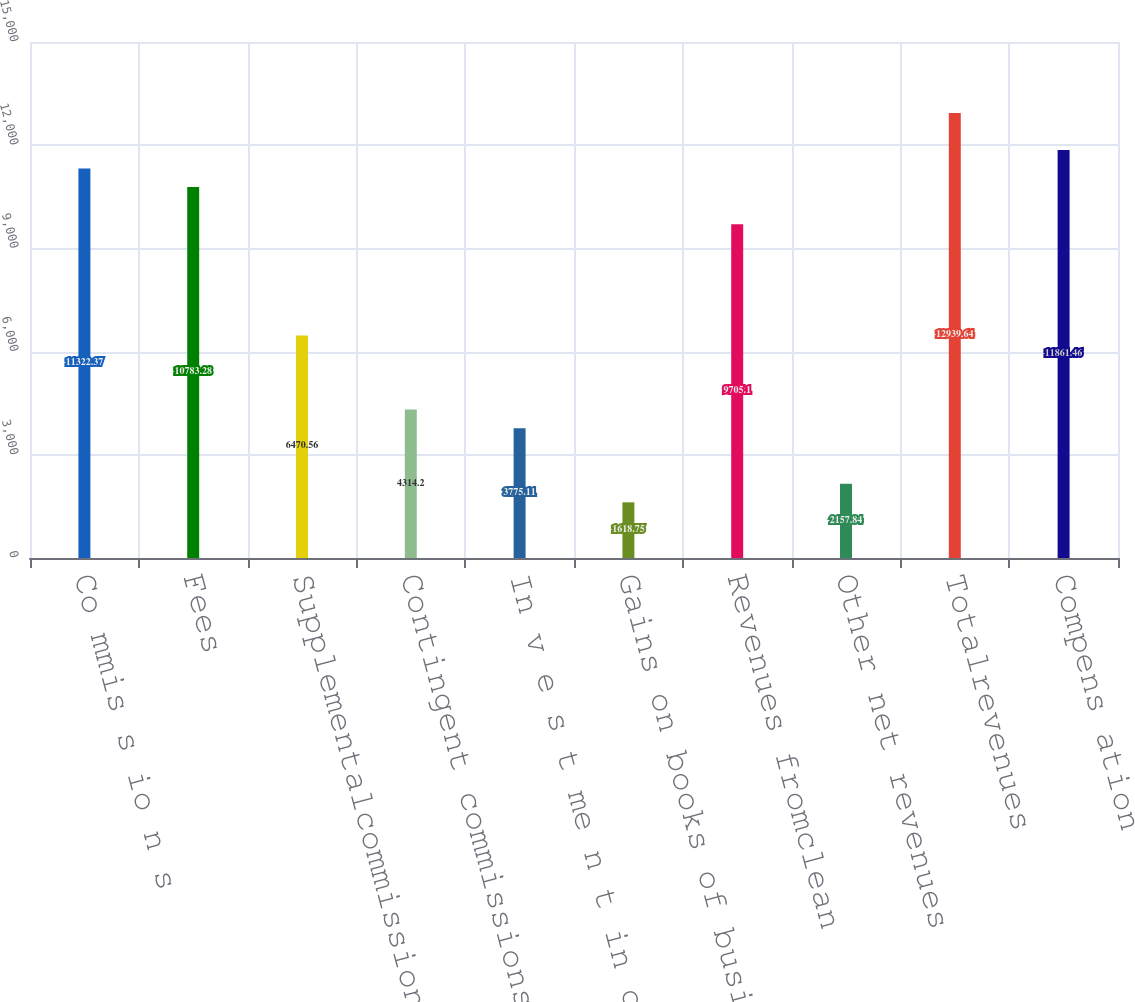Convert chart. <chart><loc_0><loc_0><loc_500><loc_500><bar_chart><fcel>Co mmis s io n s<fcel>Fees<fcel>Supplementalcommissions<fcel>Contingent commissions<fcel>In v e s t me n t in c o me<fcel>Gains on books of business<fcel>Revenues fromclean<fcel>Other net revenues<fcel>Totalrevenues<fcel>Compens ation<nl><fcel>11322.4<fcel>10783.3<fcel>6470.56<fcel>4314.2<fcel>3775.11<fcel>1618.75<fcel>9705.1<fcel>2157.84<fcel>12939.6<fcel>11861.5<nl></chart> 